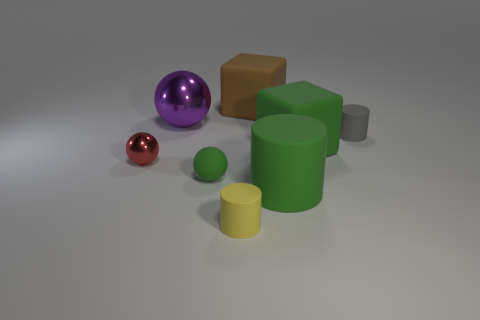There is a big matte cylinder; does it have the same color as the tiny sphere right of the red ball?
Give a very brief answer. Yes. What material is the purple object that is the same shape as the tiny red metallic thing?
Provide a succinct answer. Metal. What is the material of the sphere behind the tiny rubber cylinder behind the large cylinder on the right side of the brown matte object?
Provide a succinct answer. Metal. What is the shape of the small yellow object?
Your answer should be compact. Cylinder. What is the size of the green object behind the ball in front of the red thing?
Provide a succinct answer. Large. How many objects are big metal things or tiny green cylinders?
Your answer should be very brief. 1. Does the small yellow thing have the same shape as the gray rubber object?
Give a very brief answer. Yes. Is there another green object that has the same material as the small green object?
Give a very brief answer. Yes. Is there a matte block right of the tiny rubber thing to the right of the tiny yellow rubber cylinder?
Your answer should be compact. No. Is the size of the rubber cylinder behind the green rubber cylinder the same as the big green cube?
Keep it short and to the point. No. 